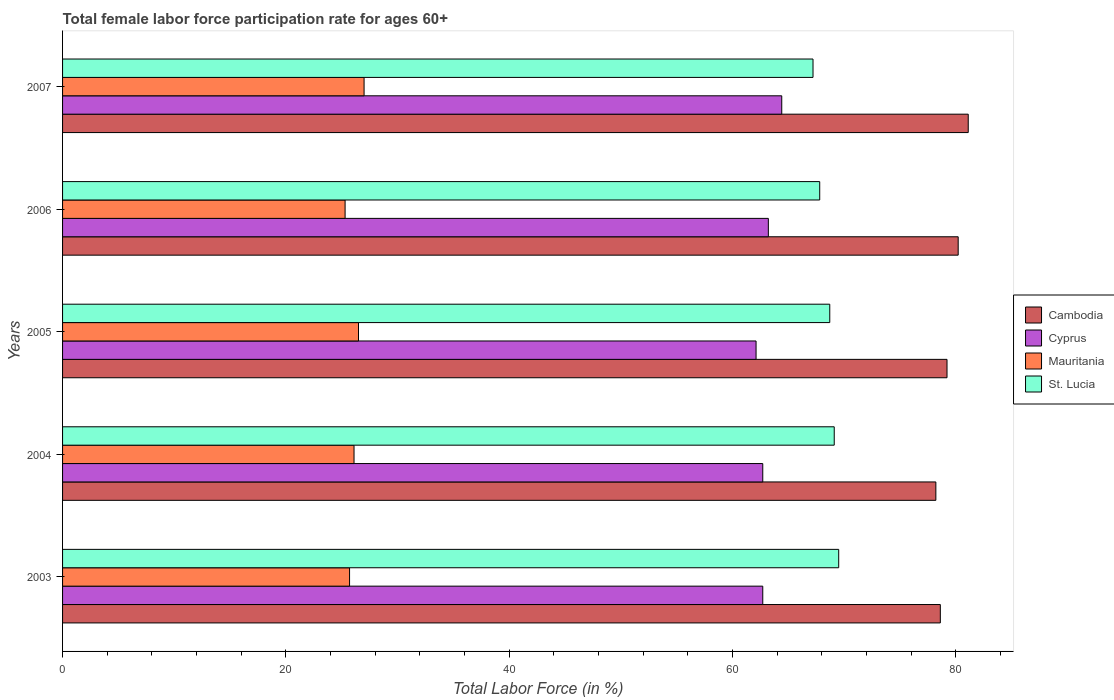How many different coloured bars are there?
Make the answer very short. 4. Are the number of bars per tick equal to the number of legend labels?
Give a very brief answer. Yes. Are the number of bars on each tick of the Y-axis equal?
Offer a very short reply. Yes. What is the label of the 2nd group of bars from the top?
Your answer should be very brief. 2006. In how many cases, is the number of bars for a given year not equal to the number of legend labels?
Your response must be concise. 0. What is the female labor force participation rate in Cyprus in 2003?
Your answer should be very brief. 62.7. Across all years, what is the maximum female labor force participation rate in Cambodia?
Your response must be concise. 81.1. Across all years, what is the minimum female labor force participation rate in Cyprus?
Ensure brevity in your answer.  62.1. In which year was the female labor force participation rate in Mauritania maximum?
Offer a very short reply. 2007. In which year was the female labor force participation rate in Mauritania minimum?
Your response must be concise. 2006. What is the total female labor force participation rate in Cambodia in the graph?
Make the answer very short. 397.3. What is the difference between the female labor force participation rate in St. Lucia in 2006 and the female labor force participation rate in Cyprus in 2003?
Give a very brief answer. 5.1. What is the average female labor force participation rate in Cambodia per year?
Give a very brief answer. 79.46. In how many years, is the female labor force participation rate in Cyprus greater than 64 %?
Provide a succinct answer. 1. What is the ratio of the female labor force participation rate in Mauritania in 2003 to that in 2005?
Offer a terse response. 0.97. Is the female labor force participation rate in St. Lucia in 2004 less than that in 2005?
Offer a terse response. No. What is the difference between the highest and the second highest female labor force participation rate in Cyprus?
Your response must be concise. 1.2. What is the difference between the highest and the lowest female labor force participation rate in Mauritania?
Your answer should be very brief. 1.7. Is the sum of the female labor force participation rate in Mauritania in 2004 and 2006 greater than the maximum female labor force participation rate in St. Lucia across all years?
Provide a short and direct response. No. Is it the case that in every year, the sum of the female labor force participation rate in Cyprus and female labor force participation rate in Cambodia is greater than the sum of female labor force participation rate in St. Lucia and female labor force participation rate in Mauritania?
Your answer should be very brief. Yes. What does the 1st bar from the top in 2007 represents?
Your response must be concise. St. Lucia. What does the 2nd bar from the bottom in 2006 represents?
Your answer should be very brief. Cyprus. Are the values on the major ticks of X-axis written in scientific E-notation?
Your answer should be compact. No. Where does the legend appear in the graph?
Keep it short and to the point. Center right. How are the legend labels stacked?
Your answer should be very brief. Vertical. What is the title of the graph?
Provide a short and direct response. Total female labor force participation rate for ages 60+. What is the label or title of the X-axis?
Provide a short and direct response. Total Labor Force (in %). What is the label or title of the Y-axis?
Keep it short and to the point. Years. What is the Total Labor Force (in %) in Cambodia in 2003?
Keep it short and to the point. 78.6. What is the Total Labor Force (in %) of Cyprus in 2003?
Make the answer very short. 62.7. What is the Total Labor Force (in %) in Mauritania in 2003?
Your answer should be compact. 25.7. What is the Total Labor Force (in %) of St. Lucia in 2003?
Give a very brief answer. 69.5. What is the Total Labor Force (in %) of Cambodia in 2004?
Provide a succinct answer. 78.2. What is the Total Labor Force (in %) in Cyprus in 2004?
Provide a succinct answer. 62.7. What is the Total Labor Force (in %) in Mauritania in 2004?
Offer a terse response. 26.1. What is the Total Labor Force (in %) of St. Lucia in 2004?
Ensure brevity in your answer.  69.1. What is the Total Labor Force (in %) in Cambodia in 2005?
Your answer should be very brief. 79.2. What is the Total Labor Force (in %) in Cyprus in 2005?
Give a very brief answer. 62.1. What is the Total Labor Force (in %) of St. Lucia in 2005?
Keep it short and to the point. 68.7. What is the Total Labor Force (in %) in Cambodia in 2006?
Provide a short and direct response. 80.2. What is the Total Labor Force (in %) of Cyprus in 2006?
Ensure brevity in your answer.  63.2. What is the Total Labor Force (in %) of Mauritania in 2006?
Give a very brief answer. 25.3. What is the Total Labor Force (in %) in St. Lucia in 2006?
Provide a short and direct response. 67.8. What is the Total Labor Force (in %) in Cambodia in 2007?
Provide a short and direct response. 81.1. What is the Total Labor Force (in %) of Cyprus in 2007?
Ensure brevity in your answer.  64.4. What is the Total Labor Force (in %) in St. Lucia in 2007?
Give a very brief answer. 67.2. Across all years, what is the maximum Total Labor Force (in %) in Cambodia?
Your answer should be compact. 81.1. Across all years, what is the maximum Total Labor Force (in %) in Cyprus?
Provide a short and direct response. 64.4. Across all years, what is the maximum Total Labor Force (in %) of St. Lucia?
Provide a succinct answer. 69.5. Across all years, what is the minimum Total Labor Force (in %) in Cambodia?
Keep it short and to the point. 78.2. Across all years, what is the minimum Total Labor Force (in %) in Cyprus?
Offer a terse response. 62.1. Across all years, what is the minimum Total Labor Force (in %) in Mauritania?
Ensure brevity in your answer.  25.3. Across all years, what is the minimum Total Labor Force (in %) of St. Lucia?
Ensure brevity in your answer.  67.2. What is the total Total Labor Force (in %) in Cambodia in the graph?
Give a very brief answer. 397.3. What is the total Total Labor Force (in %) of Cyprus in the graph?
Offer a terse response. 315.1. What is the total Total Labor Force (in %) of Mauritania in the graph?
Make the answer very short. 130.6. What is the total Total Labor Force (in %) of St. Lucia in the graph?
Make the answer very short. 342.3. What is the difference between the Total Labor Force (in %) of Cambodia in 2003 and that in 2004?
Offer a terse response. 0.4. What is the difference between the Total Labor Force (in %) in Cyprus in 2003 and that in 2004?
Give a very brief answer. 0. What is the difference between the Total Labor Force (in %) of Cyprus in 2003 and that in 2006?
Provide a short and direct response. -0.5. What is the difference between the Total Labor Force (in %) of Cambodia in 2003 and that in 2007?
Your answer should be very brief. -2.5. What is the difference between the Total Labor Force (in %) in Cambodia in 2004 and that in 2005?
Your response must be concise. -1. What is the difference between the Total Labor Force (in %) in Cambodia in 2004 and that in 2006?
Provide a short and direct response. -2. What is the difference between the Total Labor Force (in %) of Mauritania in 2004 and that in 2006?
Offer a terse response. 0.8. What is the difference between the Total Labor Force (in %) of St. Lucia in 2004 and that in 2006?
Offer a very short reply. 1.3. What is the difference between the Total Labor Force (in %) in Cyprus in 2004 and that in 2007?
Provide a succinct answer. -1.7. What is the difference between the Total Labor Force (in %) of Mauritania in 2005 and that in 2006?
Give a very brief answer. 1.2. What is the difference between the Total Labor Force (in %) of Mauritania in 2005 and that in 2007?
Provide a short and direct response. -0.5. What is the difference between the Total Labor Force (in %) in Mauritania in 2006 and that in 2007?
Offer a terse response. -1.7. What is the difference between the Total Labor Force (in %) in Cambodia in 2003 and the Total Labor Force (in %) in Mauritania in 2004?
Keep it short and to the point. 52.5. What is the difference between the Total Labor Force (in %) of Cambodia in 2003 and the Total Labor Force (in %) of St. Lucia in 2004?
Provide a succinct answer. 9.5. What is the difference between the Total Labor Force (in %) in Cyprus in 2003 and the Total Labor Force (in %) in Mauritania in 2004?
Ensure brevity in your answer.  36.6. What is the difference between the Total Labor Force (in %) in Cyprus in 2003 and the Total Labor Force (in %) in St. Lucia in 2004?
Ensure brevity in your answer.  -6.4. What is the difference between the Total Labor Force (in %) in Mauritania in 2003 and the Total Labor Force (in %) in St. Lucia in 2004?
Your answer should be very brief. -43.4. What is the difference between the Total Labor Force (in %) in Cambodia in 2003 and the Total Labor Force (in %) in Cyprus in 2005?
Offer a very short reply. 16.5. What is the difference between the Total Labor Force (in %) of Cambodia in 2003 and the Total Labor Force (in %) of Mauritania in 2005?
Give a very brief answer. 52.1. What is the difference between the Total Labor Force (in %) of Cyprus in 2003 and the Total Labor Force (in %) of Mauritania in 2005?
Make the answer very short. 36.2. What is the difference between the Total Labor Force (in %) in Mauritania in 2003 and the Total Labor Force (in %) in St. Lucia in 2005?
Your response must be concise. -43. What is the difference between the Total Labor Force (in %) in Cambodia in 2003 and the Total Labor Force (in %) in Mauritania in 2006?
Provide a succinct answer. 53.3. What is the difference between the Total Labor Force (in %) in Cambodia in 2003 and the Total Labor Force (in %) in St. Lucia in 2006?
Offer a very short reply. 10.8. What is the difference between the Total Labor Force (in %) in Cyprus in 2003 and the Total Labor Force (in %) in Mauritania in 2006?
Ensure brevity in your answer.  37.4. What is the difference between the Total Labor Force (in %) of Mauritania in 2003 and the Total Labor Force (in %) of St. Lucia in 2006?
Your response must be concise. -42.1. What is the difference between the Total Labor Force (in %) in Cambodia in 2003 and the Total Labor Force (in %) in Mauritania in 2007?
Offer a very short reply. 51.6. What is the difference between the Total Labor Force (in %) in Cyprus in 2003 and the Total Labor Force (in %) in Mauritania in 2007?
Offer a very short reply. 35.7. What is the difference between the Total Labor Force (in %) of Cyprus in 2003 and the Total Labor Force (in %) of St. Lucia in 2007?
Ensure brevity in your answer.  -4.5. What is the difference between the Total Labor Force (in %) of Mauritania in 2003 and the Total Labor Force (in %) of St. Lucia in 2007?
Keep it short and to the point. -41.5. What is the difference between the Total Labor Force (in %) of Cambodia in 2004 and the Total Labor Force (in %) of Mauritania in 2005?
Offer a very short reply. 51.7. What is the difference between the Total Labor Force (in %) in Cyprus in 2004 and the Total Labor Force (in %) in Mauritania in 2005?
Offer a very short reply. 36.2. What is the difference between the Total Labor Force (in %) of Mauritania in 2004 and the Total Labor Force (in %) of St. Lucia in 2005?
Make the answer very short. -42.6. What is the difference between the Total Labor Force (in %) of Cambodia in 2004 and the Total Labor Force (in %) of Cyprus in 2006?
Ensure brevity in your answer.  15. What is the difference between the Total Labor Force (in %) of Cambodia in 2004 and the Total Labor Force (in %) of Mauritania in 2006?
Your answer should be compact. 52.9. What is the difference between the Total Labor Force (in %) of Cambodia in 2004 and the Total Labor Force (in %) of St. Lucia in 2006?
Provide a short and direct response. 10.4. What is the difference between the Total Labor Force (in %) in Cyprus in 2004 and the Total Labor Force (in %) in Mauritania in 2006?
Provide a succinct answer. 37.4. What is the difference between the Total Labor Force (in %) in Mauritania in 2004 and the Total Labor Force (in %) in St. Lucia in 2006?
Ensure brevity in your answer.  -41.7. What is the difference between the Total Labor Force (in %) of Cambodia in 2004 and the Total Labor Force (in %) of Cyprus in 2007?
Offer a very short reply. 13.8. What is the difference between the Total Labor Force (in %) in Cambodia in 2004 and the Total Labor Force (in %) in Mauritania in 2007?
Offer a terse response. 51.2. What is the difference between the Total Labor Force (in %) in Cambodia in 2004 and the Total Labor Force (in %) in St. Lucia in 2007?
Offer a terse response. 11. What is the difference between the Total Labor Force (in %) of Cyprus in 2004 and the Total Labor Force (in %) of Mauritania in 2007?
Keep it short and to the point. 35.7. What is the difference between the Total Labor Force (in %) in Mauritania in 2004 and the Total Labor Force (in %) in St. Lucia in 2007?
Keep it short and to the point. -41.1. What is the difference between the Total Labor Force (in %) of Cambodia in 2005 and the Total Labor Force (in %) of Cyprus in 2006?
Provide a succinct answer. 16. What is the difference between the Total Labor Force (in %) of Cambodia in 2005 and the Total Labor Force (in %) of Mauritania in 2006?
Your answer should be very brief. 53.9. What is the difference between the Total Labor Force (in %) in Cyprus in 2005 and the Total Labor Force (in %) in Mauritania in 2006?
Your answer should be compact. 36.8. What is the difference between the Total Labor Force (in %) in Cyprus in 2005 and the Total Labor Force (in %) in St. Lucia in 2006?
Your response must be concise. -5.7. What is the difference between the Total Labor Force (in %) of Mauritania in 2005 and the Total Labor Force (in %) of St. Lucia in 2006?
Provide a short and direct response. -41.3. What is the difference between the Total Labor Force (in %) of Cambodia in 2005 and the Total Labor Force (in %) of Mauritania in 2007?
Ensure brevity in your answer.  52.2. What is the difference between the Total Labor Force (in %) of Cyprus in 2005 and the Total Labor Force (in %) of Mauritania in 2007?
Keep it short and to the point. 35.1. What is the difference between the Total Labor Force (in %) of Cyprus in 2005 and the Total Labor Force (in %) of St. Lucia in 2007?
Keep it short and to the point. -5.1. What is the difference between the Total Labor Force (in %) in Mauritania in 2005 and the Total Labor Force (in %) in St. Lucia in 2007?
Offer a terse response. -40.7. What is the difference between the Total Labor Force (in %) in Cambodia in 2006 and the Total Labor Force (in %) in Cyprus in 2007?
Your answer should be compact. 15.8. What is the difference between the Total Labor Force (in %) in Cambodia in 2006 and the Total Labor Force (in %) in Mauritania in 2007?
Your response must be concise. 53.2. What is the difference between the Total Labor Force (in %) of Cambodia in 2006 and the Total Labor Force (in %) of St. Lucia in 2007?
Ensure brevity in your answer.  13. What is the difference between the Total Labor Force (in %) in Cyprus in 2006 and the Total Labor Force (in %) in Mauritania in 2007?
Your answer should be compact. 36.2. What is the difference between the Total Labor Force (in %) of Cyprus in 2006 and the Total Labor Force (in %) of St. Lucia in 2007?
Your answer should be compact. -4. What is the difference between the Total Labor Force (in %) of Mauritania in 2006 and the Total Labor Force (in %) of St. Lucia in 2007?
Provide a short and direct response. -41.9. What is the average Total Labor Force (in %) in Cambodia per year?
Keep it short and to the point. 79.46. What is the average Total Labor Force (in %) of Cyprus per year?
Make the answer very short. 63.02. What is the average Total Labor Force (in %) of Mauritania per year?
Offer a very short reply. 26.12. What is the average Total Labor Force (in %) of St. Lucia per year?
Your answer should be compact. 68.46. In the year 2003, what is the difference between the Total Labor Force (in %) of Cambodia and Total Labor Force (in %) of Cyprus?
Give a very brief answer. 15.9. In the year 2003, what is the difference between the Total Labor Force (in %) in Cambodia and Total Labor Force (in %) in Mauritania?
Provide a short and direct response. 52.9. In the year 2003, what is the difference between the Total Labor Force (in %) in Cyprus and Total Labor Force (in %) in Mauritania?
Ensure brevity in your answer.  37. In the year 2003, what is the difference between the Total Labor Force (in %) in Cyprus and Total Labor Force (in %) in St. Lucia?
Make the answer very short. -6.8. In the year 2003, what is the difference between the Total Labor Force (in %) of Mauritania and Total Labor Force (in %) of St. Lucia?
Your response must be concise. -43.8. In the year 2004, what is the difference between the Total Labor Force (in %) of Cambodia and Total Labor Force (in %) of Mauritania?
Give a very brief answer. 52.1. In the year 2004, what is the difference between the Total Labor Force (in %) of Cambodia and Total Labor Force (in %) of St. Lucia?
Your answer should be compact. 9.1. In the year 2004, what is the difference between the Total Labor Force (in %) in Cyprus and Total Labor Force (in %) in Mauritania?
Your response must be concise. 36.6. In the year 2004, what is the difference between the Total Labor Force (in %) of Mauritania and Total Labor Force (in %) of St. Lucia?
Keep it short and to the point. -43. In the year 2005, what is the difference between the Total Labor Force (in %) in Cambodia and Total Labor Force (in %) in Cyprus?
Your answer should be very brief. 17.1. In the year 2005, what is the difference between the Total Labor Force (in %) of Cambodia and Total Labor Force (in %) of Mauritania?
Make the answer very short. 52.7. In the year 2005, what is the difference between the Total Labor Force (in %) in Cambodia and Total Labor Force (in %) in St. Lucia?
Make the answer very short. 10.5. In the year 2005, what is the difference between the Total Labor Force (in %) in Cyprus and Total Labor Force (in %) in Mauritania?
Keep it short and to the point. 35.6. In the year 2005, what is the difference between the Total Labor Force (in %) in Cyprus and Total Labor Force (in %) in St. Lucia?
Give a very brief answer. -6.6. In the year 2005, what is the difference between the Total Labor Force (in %) in Mauritania and Total Labor Force (in %) in St. Lucia?
Your response must be concise. -42.2. In the year 2006, what is the difference between the Total Labor Force (in %) of Cambodia and Total Labor Force (in %) of Cyprus?
Ensure brevity in your answer.  17. In the year 2006, what is the difference between the Total Labor Force (in %) in Cambodia and Total Labor Force (in %) in Mauritania?
Provide a short and direct response. 54.9. In the year 2006, what is the difference between the Total Labor Force (in %) of Cyprus and Total Labor Force (in %) of Mauritania?
Provide a succinct answer. 37.9. In the year 2006, what is the difference between the Total Labor Force (in %) of Mauritania and Total Labor Force (in %) of St. Lucia?
Give a very brief answer. -42.5. In the year 2007, what is the difference between the Total Labor Force (in %) of Cambodia and Total Labor Force (in %) of Mauritania?
Make the answer very short. 54.1. In the year 2007, what is the difference between the Total Labor Force (in %) in Cambodia and Total Labor Force (in %) in St. Lucia?
Your response must be concise. 13.9. In the year 2007, what is the difference between the Total Labor Force (in %) of Cyprus and Total Labor Force (in %) of Mauritania?
Your answer should be compact. 37.4. In the year 2007, what is the difference between the Total Labor Force (in %) of Cyprus and Total Labor Force (in %) of St. Lucia?
Provide a short and direct response. -2.8. In the year 2007, what is the difference between the Total Labor Force (in %) of Mauritania and Total Labor Force (in %) of St. Lucia?
Offer a terse response. -40.2. What is the ratio of the Total Labor Force (in %) of Cambodia in 2003 to that in 2004?
Your answer should be very brief. 1.01. What is the ratio of the Total Labor Force (in %) of Cyprus in 2003 to that in 2004?
Make the answer very short. 1. What is the ratio of the Total Labor Force (in %) in Mauritania in 2003 to that in 2004?
Make the answer very short. 0.98. What is the ratio of the Total Labor Force (in %) of St. Lucia in 2003 to that in 2004?
Keep it short and to the point. 1.01. What is the ratio of the Total Labor Force (in %) of Cyprus in 2003 to that in 2005?
Provide a succinct answer. 1.01. What is the ratio of the Total Labor Force (in %) in Mauritania in 2003 to that in 2005?
Provide a succinct answer. 0.97. What is the ratio of the Total Labor Force (in %) of St. Lucia in 2003 to that in 2005?
Ensure brevity in your answer.  1.01. What is the ratio of the Total Labor Force (in %) in Cambodia in 2003 to that in 2006?
Keep it short and to the point. 0.98. What is the ratio of the Total Labor Force (in %) in Cyprus in 2003 to that in 2006?
Offer a terse response. 0.99. What is the ratio of the Total Labor Force (in %) in Mauritania in 2003 to that in 2006?
Provide a short and direct response. 1.02. What is the ratio of the Total Labor Force (in %) in St. Lucia in 2003 to that in 2006?
Your response must be concise. 1.03. What is the ratio of the Total Labor Force (in %) in Cambodia in 2003 to that in 2007?
Provide a short and direct response. 0.97. What is the ratio of the Total Labor Force (in %) of Cyprus in 2003 to that in 2007?
Provide a succinct answer. 0.97. What is the ratio of the Total Labor Force (in %) of Mauritania in 2003 to that in 2007?
Keep it short and to the point. 0.95. What is the ratio of the Total Labor Force (in %) of St. Lucia in 2003 to that in 2007?
Keep it short and to the point. 1.03. What is the ratio of the Total Labor Force (in %) in Cambodia in 2004 to that in 2005?
Keep it short and to the point. 0.99. What is the ratio of the Total Labor Force (in %) in Cyprus in 2004 to that in 2005?
Offer a terse response. 1.01. What is the ratio of the Total Labor Force (in %) in Mauritania in 2004 to that in 2005?
Give a very brief answer. 0.98. What is the ratio of the Total Labor Force (in %) in Cambodia in 2004 to that in 2006?
Your answer should be very brief. 0.98. What is the ratio of the Total Labor Force (in %) of Mauritania in 2004 to that in 2006?
Your answer should be compact. 1.03. What is the ratio of the Total Labor Force (in %) of St. Lucia in 2004 to that in 2006?
Provide a short and direct response. 1.02. What is the ratio of the Total Labor Force (in %) of Cambodia in 2004 to that in 2007?
Your answer should be compact. 0.96. What is the ratio of the Total Labor Force (in %) of Cyprus in 2004 to that in 2007?
Provide a succinct answer. 0.97. What is the ratio of the Total Labor Force (in %) of Mauritania in 2004 to that in 2007?
Provide a succinct answer. 0.97. What is the ratio of the Total Labor Force (in %) in St. Lucia in 2004 to that in 2007?
Offer a terse response. 1.03. What is the ratio of the Total Labor Force (in %) of Cambodia in 2005 to that in 2006?
Offer a very short reply. 0.99. What is the ratio of the Total Labor Force (in %) in Cyprus in 2005 to that in 2006?
Your answer should be compact. 0.98. What is the ratio of the Total Labor Force (in %) in Mauritania in 2005 to that in 2006?
Your answer should be compact. 1.05. What is the ratio of the Total Labor Force (in %) of St. Lucia in 2005 to that in 2006?
Offer a very short reply. 1.01. What is the ratio of the Total Labor Force (in %) in Cambodia in 2005 to that in 2007?
Make the answer very short. 0.98. What is the ratio of the Total Labor Force (in %) in Cyprus in 2005 to that in 2007?
Provide a short and direct response. 0.96. What is the ratio of the Total Labor Force (in %) in Mauritania in 2005 to that in 2007?
Your answer should be compact. 0.98. What is the ratio of the Total Labor Force (in %) in St. Lucia in 2005 to that in 2007?
Offer a very short reply. 1.02. What is the ratio of the Total Labor Force (in %) of Cambodia in 2006 to that in 2007?
Your answer should be compact. 0.99. What is the ratio of the Total Labor Force (in %) in Cyprus in 2006 to that in 2007?
Make the answer very short. 0.98. What is the ratio of the Total Labor Force (in %) in Mauritania in 2006 to that in 2007?
Provide a short and direct response. 0.94. What is the ratio of the Total Labor Force (in %) of St. Lucia in 2006 to that in 2007?
Give a very brief answer. 1.01. What is the difference between the highest and the second highest Total Labor Force (in %) in Cambodia?
Your response must be concise. 0.9. What is the difference between the highest and the second highest Total Labor Force (in %) in Mauritania?
Ensure brevity in your answer.  0.5. What is the difference between the highest and the second highest Total Labor Force (in %) of St. Lucia?
Offer a terse response. 0.4. What is the difference between the highest and the lowest Total Labor Force (in %) of Cyprus?
Make the answer very short. 2.3. What is the difference between the highest and the lowest Total Labor Force (in %) of St. Lucia?
Provide a short and direct response. 2.3. 